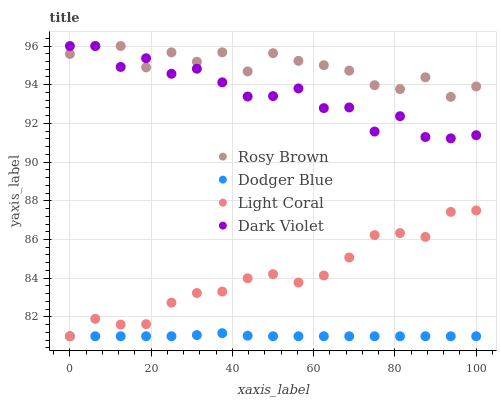Does Dodger Blue have the minimum area under the curve?
Answer yes or no. Yes. Does Rosy Brown have the maximum area under the curve?
Answer yes or no. Yes. Does Rosy Brown have the minimum area under the curve?
Answer yes or no. No. Does Dodger Blue have the maximum area under the curve?
Answer yes or no. No. Is Dodger Blue the smoothest?
Answer yes or no. Yes. Is Dark Violet the roughest?
Answer yes or no. Yes. Is Rosy Brown the smoothest?
Answer yes or no. No. Is Rosy Brown the roughest?
Answer yes or no. No. Does Light Coral have the lowest value?
Answer yes or no. Yes. Does Rosy Brown have the lowest value?
Answer yes or no. No. Does Dark Violet have the highest value?
Answer yes or no. Yes. Does Dodger Blue have the highest value?
Answer yes or no. No. Is Dodger Blue less than Dark Violet?
Answer yes or no. Yes. Is Dark Violet greater than Dodger Blue?
Answer yes or no. Yes. Does Rosy Brown intersect Dark Violet?
Answer yes or no. Yes. Is Rosy Brown less than Dark Violet?
Answer yes or no. No. Is Rosy Brown greater than Dark Violet?
Answer yes or no. No. Does Dodger Blue intersect Dark Violet?
Answer yes or no. No. 